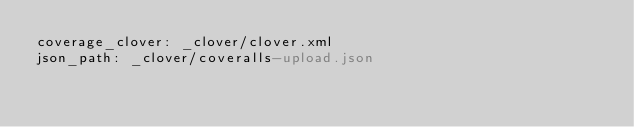Convert code to text. <code><loc_0><loc_0><loc_500><loc_500><_YAML_>coverage_clover: _clover/clover.xml
json_path: _clover/coveralls-upload.json
</code> 